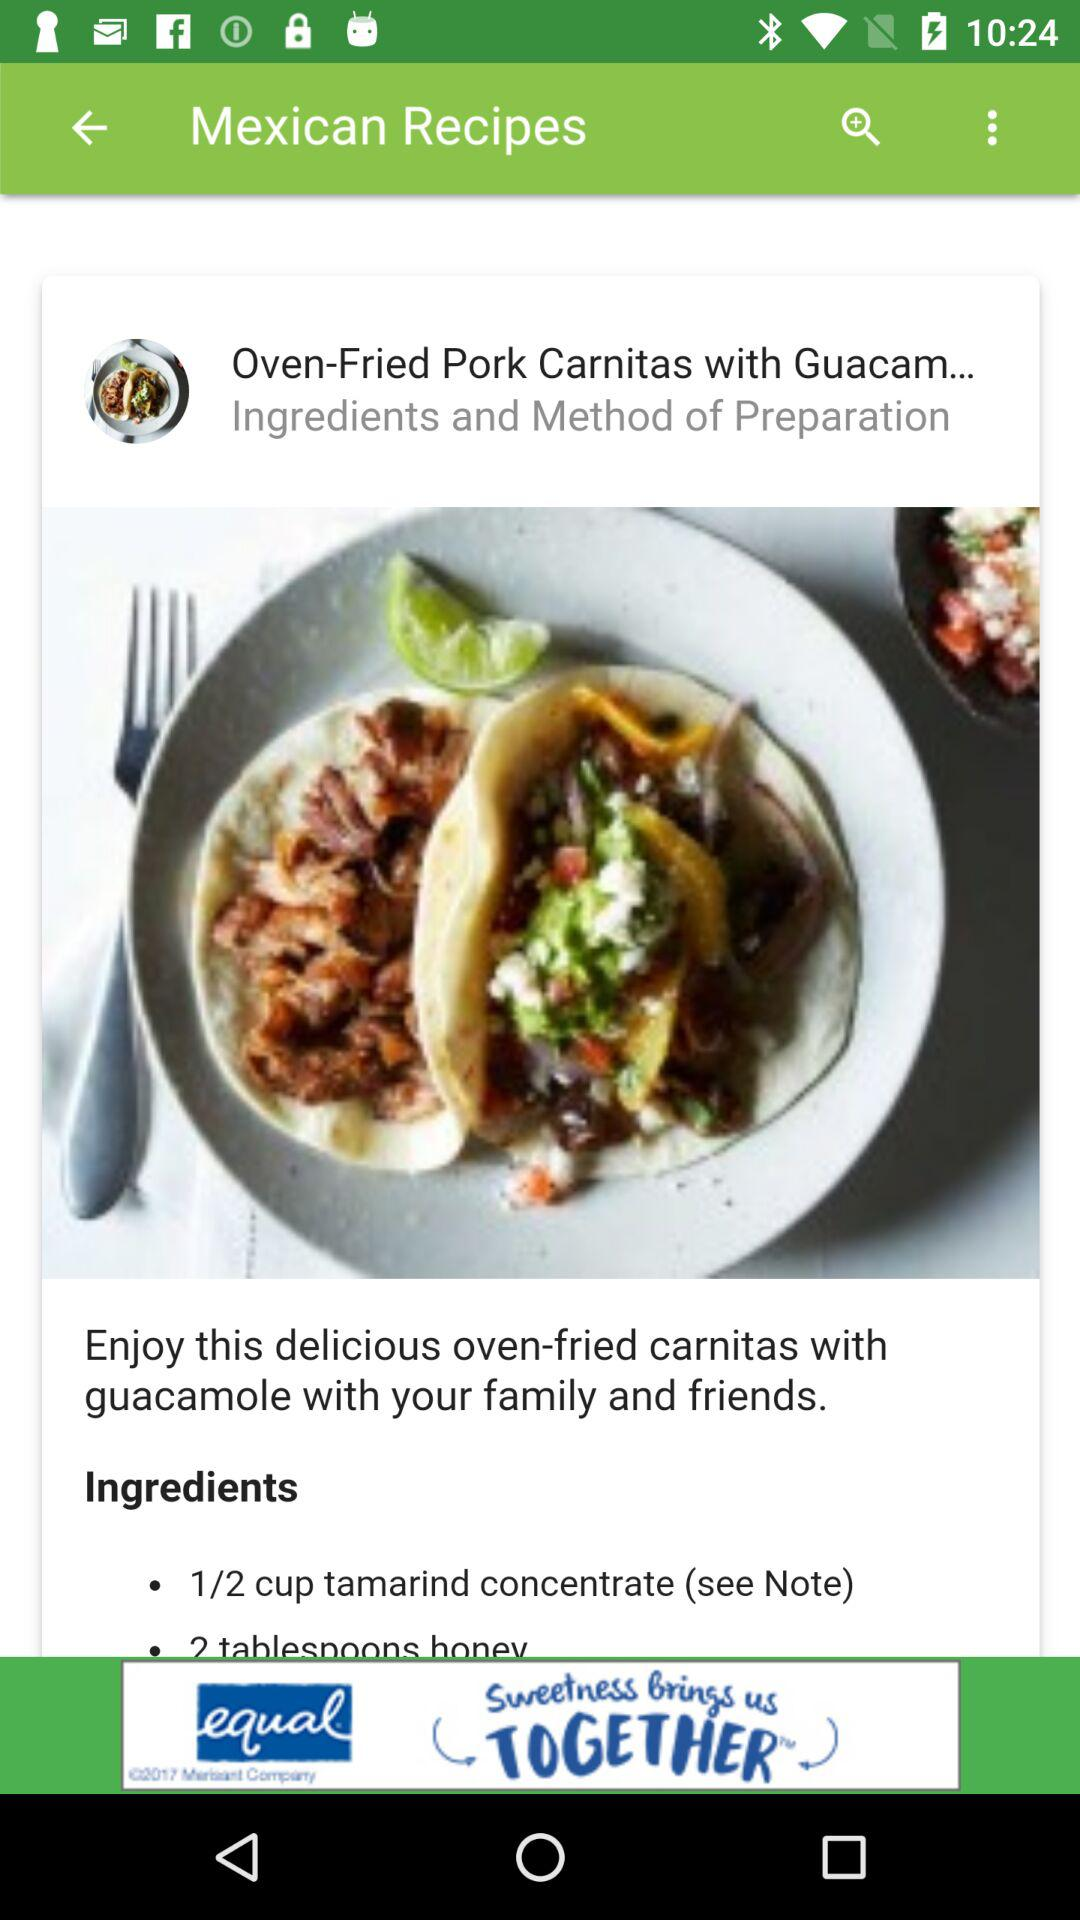What is the quantity of tamarind concentrate? The quantity of tamarind concentrate is 1/2 cup. 